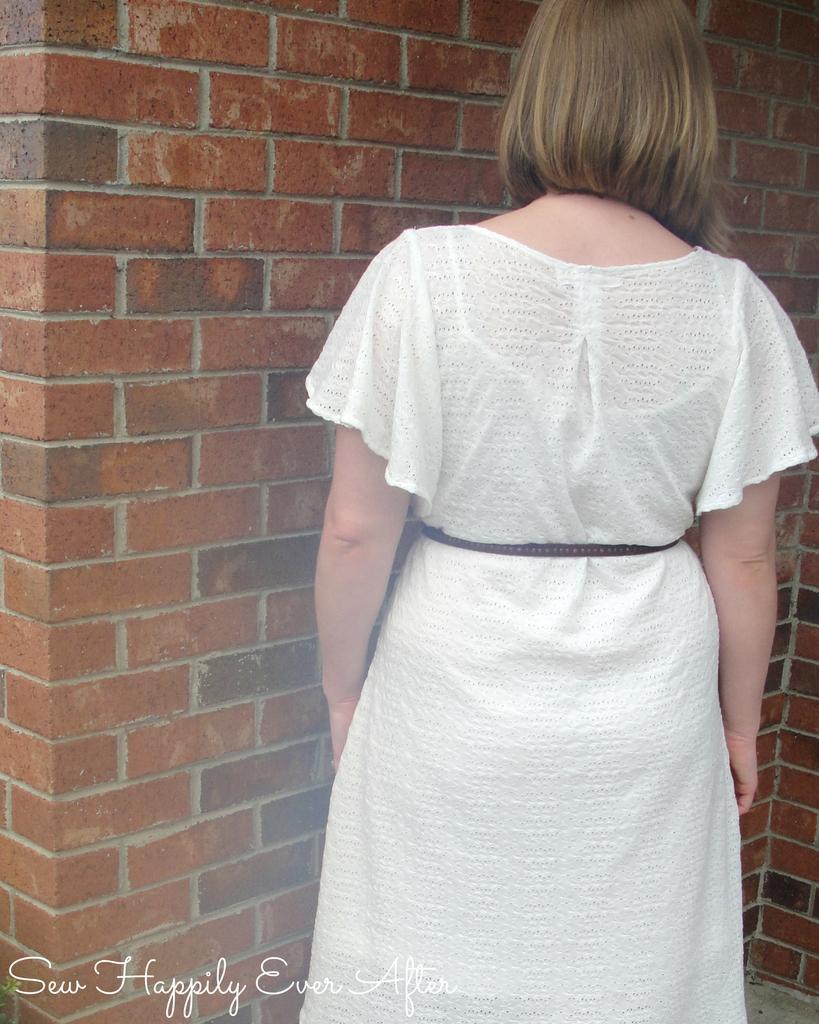Can you describe this image briefly? In this image I see a woman who is wearing white dress and I see the brick wall and I see the watermark over here. 